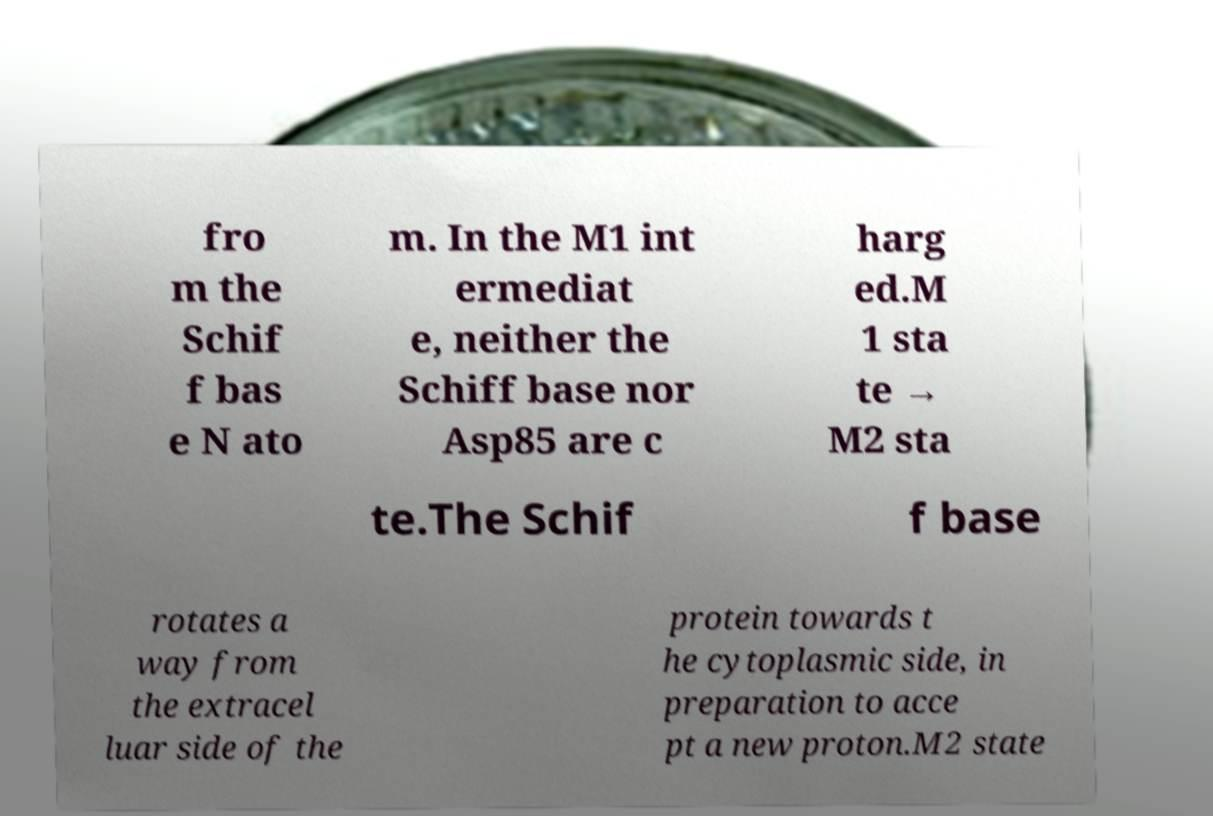Could you extract and type out the text from this image? fro m the Schif f bas e N ato m. In the M1 int ermediat e, neither the Schiff base nor Asp85 are c harg ed.M 1 sta te → M2 sta te.The Schif f base rotates a way from the extracel luar side of the protein towards t he cytoplasmic side, in preparation to acce pt a new proton.M2 state 